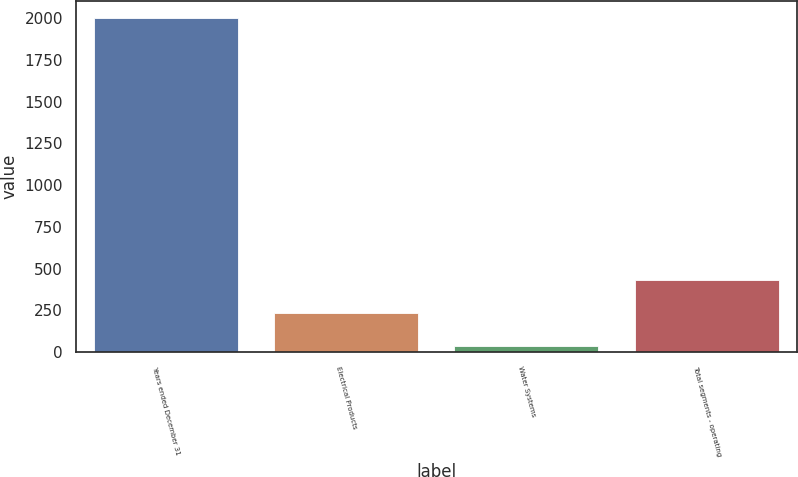<chart> <loc_0><loc_0><loc_500><loc_500><bar_chart><fcel>Years ended December 31<fcel>Electrical Products<fcel>Water Systems<fcel>Total segments - operating<nl><fcel>2004<fcel>233.52<fcel>36.8<fcel>430.24<nl></chart> 